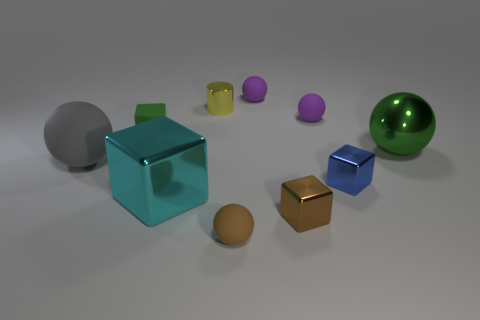Subtract all small spheres. How many spheres are left? 2 Subtract all red cylinders. How many purple spheres are left? 2 Subtract 1 blocks. How many blocks are left? 3 Subtract all green spheres. How many spheres are left? 4 Subtract all cylinders. How many objects are left? 9 Subtract all brown cubes. Subtract all brown cylinders. How many cubes are left? 3 Add 5 gray things. How many gray things exist? 6 Subtract 0 red spheres. How many objects are left? 10 Subtract all small red rubber cylinders. Subtract all big matte spheres. How many objects are left? 9 Add 2 small things. How many small things are left? 9 